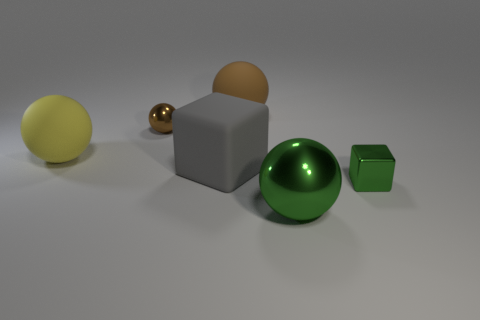What is the size of the brown object that is the same material as the gray thing?
Ensure brevity in your answer.  Large. There is a thing that is to the left of the green block and on the right side of the large brown matte thing; what is its shape?
Ensure brevity in your answer.  Sphere. There is a green thing on the right side of the green thing left of the green cube; what size is it?
Offer a very short reply. Small. How many other objects are the same color as the big metallic thing?
Keep it short and to the point. 1. What is the material of the yellow thing?
Provide a short and direct response. Rubber. Are any small blue matte balls visible?
Your answer should be compact. No. Are there an equal number of things that are behind the tiny brown object and big metallic things?
Your answer should be very brief. Yes. How many big things are either gray cubes or gray metal cylinders?
Your answer should be compact. 1. There is another thing that is the same color as the large metallic thing; what is its shape?
Provide a short and direct response. Cube. Is the sphere right of the large brown rubber ball made of the same material as the tiny brown ball?
Keep it short and to the point. Yes. 